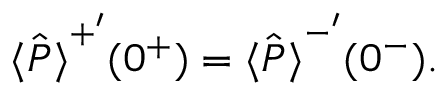<formula> <loc_0><loc_0><loc_500><loc_500>\begin{array} { r } { \hat { \langle P \rangle } ^ { + ^ { \prime } } ( 0 ^ { + } ) = \hat { \langle P \rangle } ^ { - ^ { \prime } } ( 0 ^ { - } ) . } \end{array}</formula> 